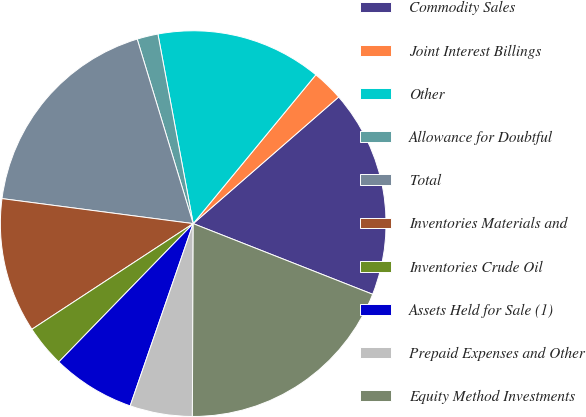Convert chart to OTSL. <chart><loc_0><loc_0><loc_500><loc_500><pie_chart><fcel>Commodity Sales<fcel>Joint Interest Billings<fcel>Other<fcel>Allowance for Doubtful<fcel>Total<fcel>Inventories Materials and<fcel>Inventories Crude Oil<fcel>Assets Held for Sale (1)<fcel>Prepaid Expenses and Other<fcel>Equity Method Investments<nl><fcel>17.37%<fcel>2.63%<fcel>13.9%<fcel>1.76%<fcel>18.24%<fcel>11.3%<fcel>3.5%<fcel>6.97%<fcel>5.23%<fcel>19.1%<nl></chart> 